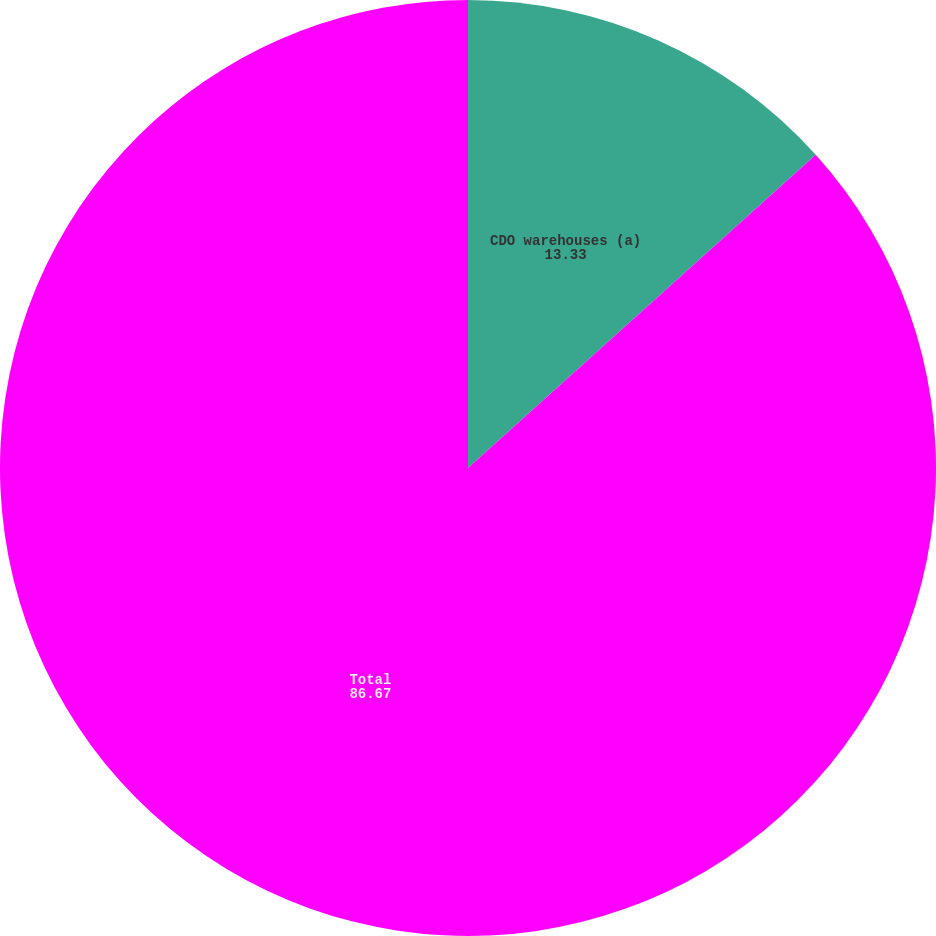Convert chart to OTSL. <chart><loc_0><loc_0><loc_500><loc_500><pie_chart><fcel>CDO warehouses (a)<fcel>Total<nl><fcel>13.33%<fcel>86.67%<nl></chart> 